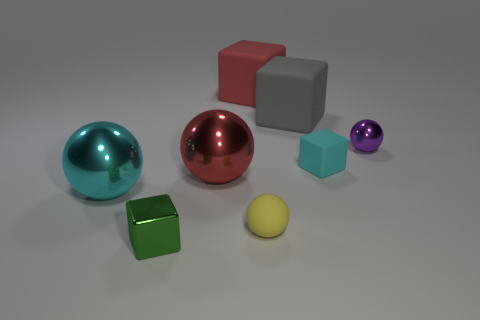Are there an equal number of shiny blocks in front of the small green cube and large cyan rubber cylinders?
Give a very brief answer. Yes. How many objects are either tiny rubber objects that are in front of the cyan block or big things?
Provide a succinct answer. 5. The shiny thing that is both behind the large cyan metal thing and left of the yellow thing has what shape?
Your response must be concise. Sphere. What number of objects are spheres that are on the left side of the large gray rubber cube or small rubber objects that are behind the small rubber sphere?
Ensure brevity in your answer.  4. How many other things are the same size as the cyan ball?
Keep it short and to the point. 3. Does the large metal ball that is on the left side of the tiny green cube have the same color as the small shiny block?
Keep it short and to the point. No. How big is the object that is in front of the tiny purple shiny sphere and behind the red shiny object?
Your answer should be very brief. Small. What number of tiny objects are red shiny objects or purple shiny objects?
Make the answer very short. 1. There is a cyan shiny thing to the left of the metal cube; what shape is it?
Your response must be concise. Sphere. How many gray blocks are there?
Keep it short and to the point. 1. 